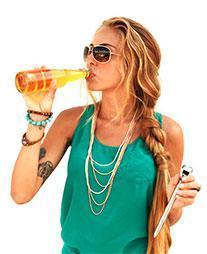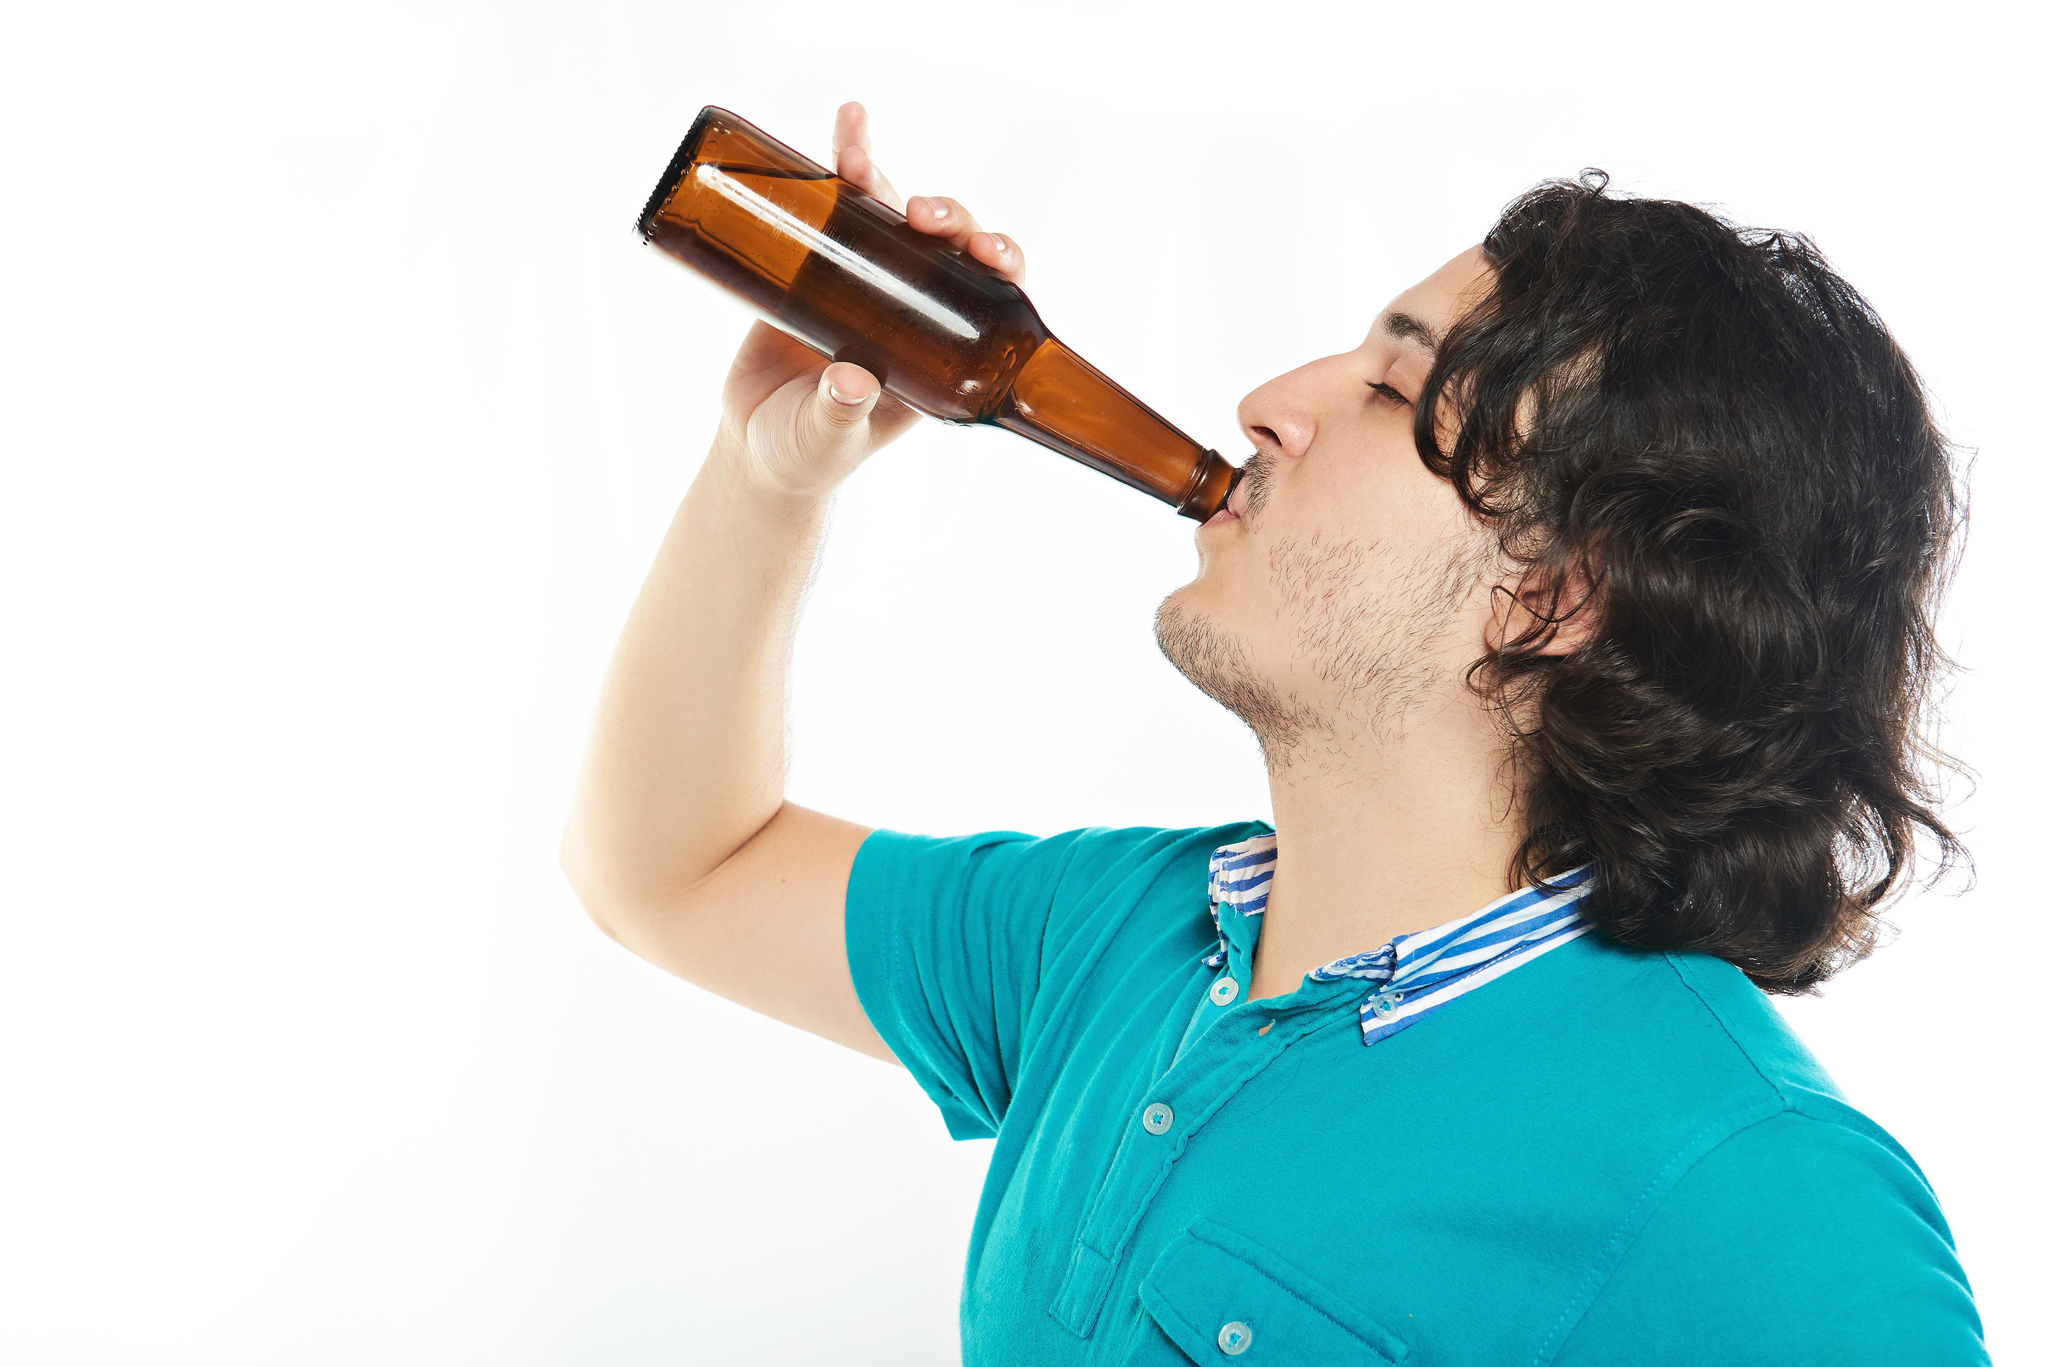The first image is the image on the left, the second image is the image on the right. Considering the images on both sides, is "There are two men and two bottles." valid? Answer yes or no. No. 